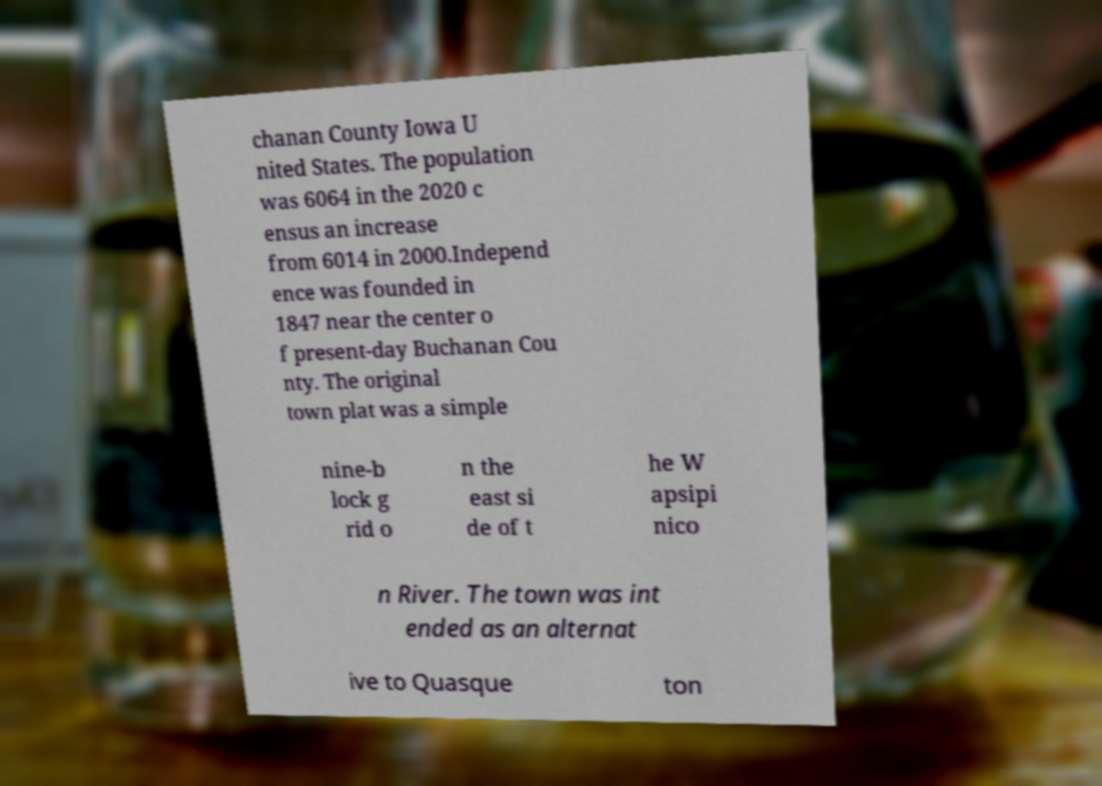Could you extract and type out the text from this image? chanan County Iowa U nited States. The population was 6064 in the 2020 c ensus an increase from 6014 in 2000.Independ ence was founded in 1847 near the center o f present-day Buchanan Cou nty. The original town plat was a simple nine-b lock g rid o n the east si de of t he W apsipi nico n River. The town was int ended as an alternat ive to Quasque ton 